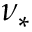Convert formula to latex. <formula><loc_0><loc_0><loc_500><loc_500>\nu _ { \ast }</formula> 